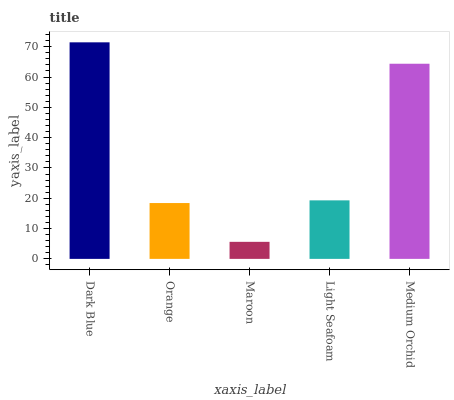Is Maroon the minimum?
Answer yes or no. Yes. Is Dark Blue the maximum?
Answer yes or no. Yes. Is Orange the minimum?
Answer yes or no. No. Is Orange the maximum?
Answer yes or no. No. Is Dark Blue greater than Orange?
Answer yes or no. Yes. Is Orange less than Dark Blue?
Answer yes or no. Yes. Is Orange greater than Dark Blue?
Answer yes or no. No. Is Dark Blue less than Orange?
Answer yes or no. No. Is Light Seafoam the high median?
Answer yes or no. Yes. Is Light Seafoam the low median?
Answer yes or no. Yes. Is Dark Blue the high median?
Answer yes or no. No. Is Medium Orchid the low median?
Answer yes or no. No. 